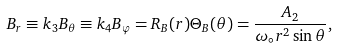<formula> <loc_0><loc_0><loc_500><loc_500>B _ { r } \equiv k _ { 3 } B _ { \theta } \equiv k _ { 4 } B _ { \varphi } = R _ { B } ( r ) \Theta _ { B } ( \theta ) = \frac { A _ { 2 } } { \omega _ { \circ } r ^ { 2 } \sin \theta } ,</formula> 